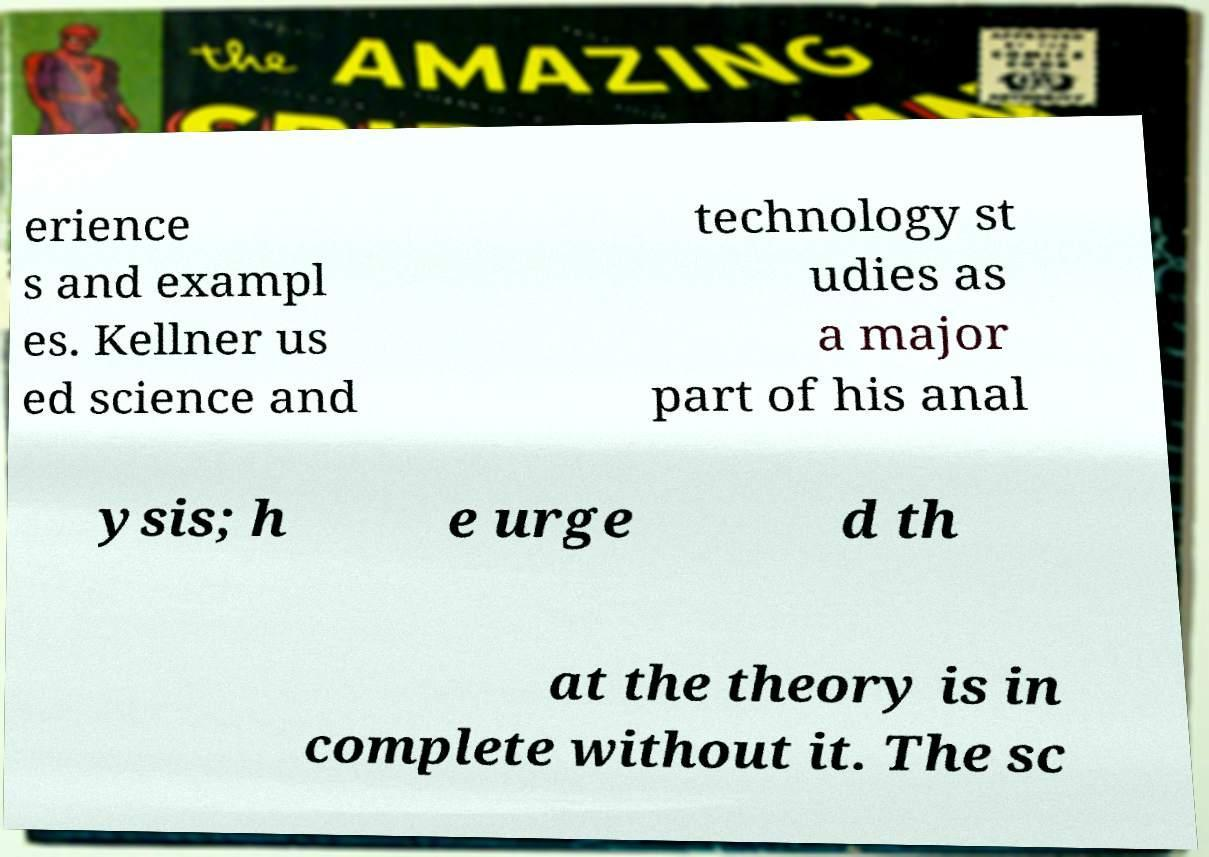What messages or text are displayed in this image? I need them in a readable, typed format. erience s and exampl es. Kellner us ed science and technology st udies as a major part of his anal ysis; h e urge d th at the theory is in complete without it. The sc 